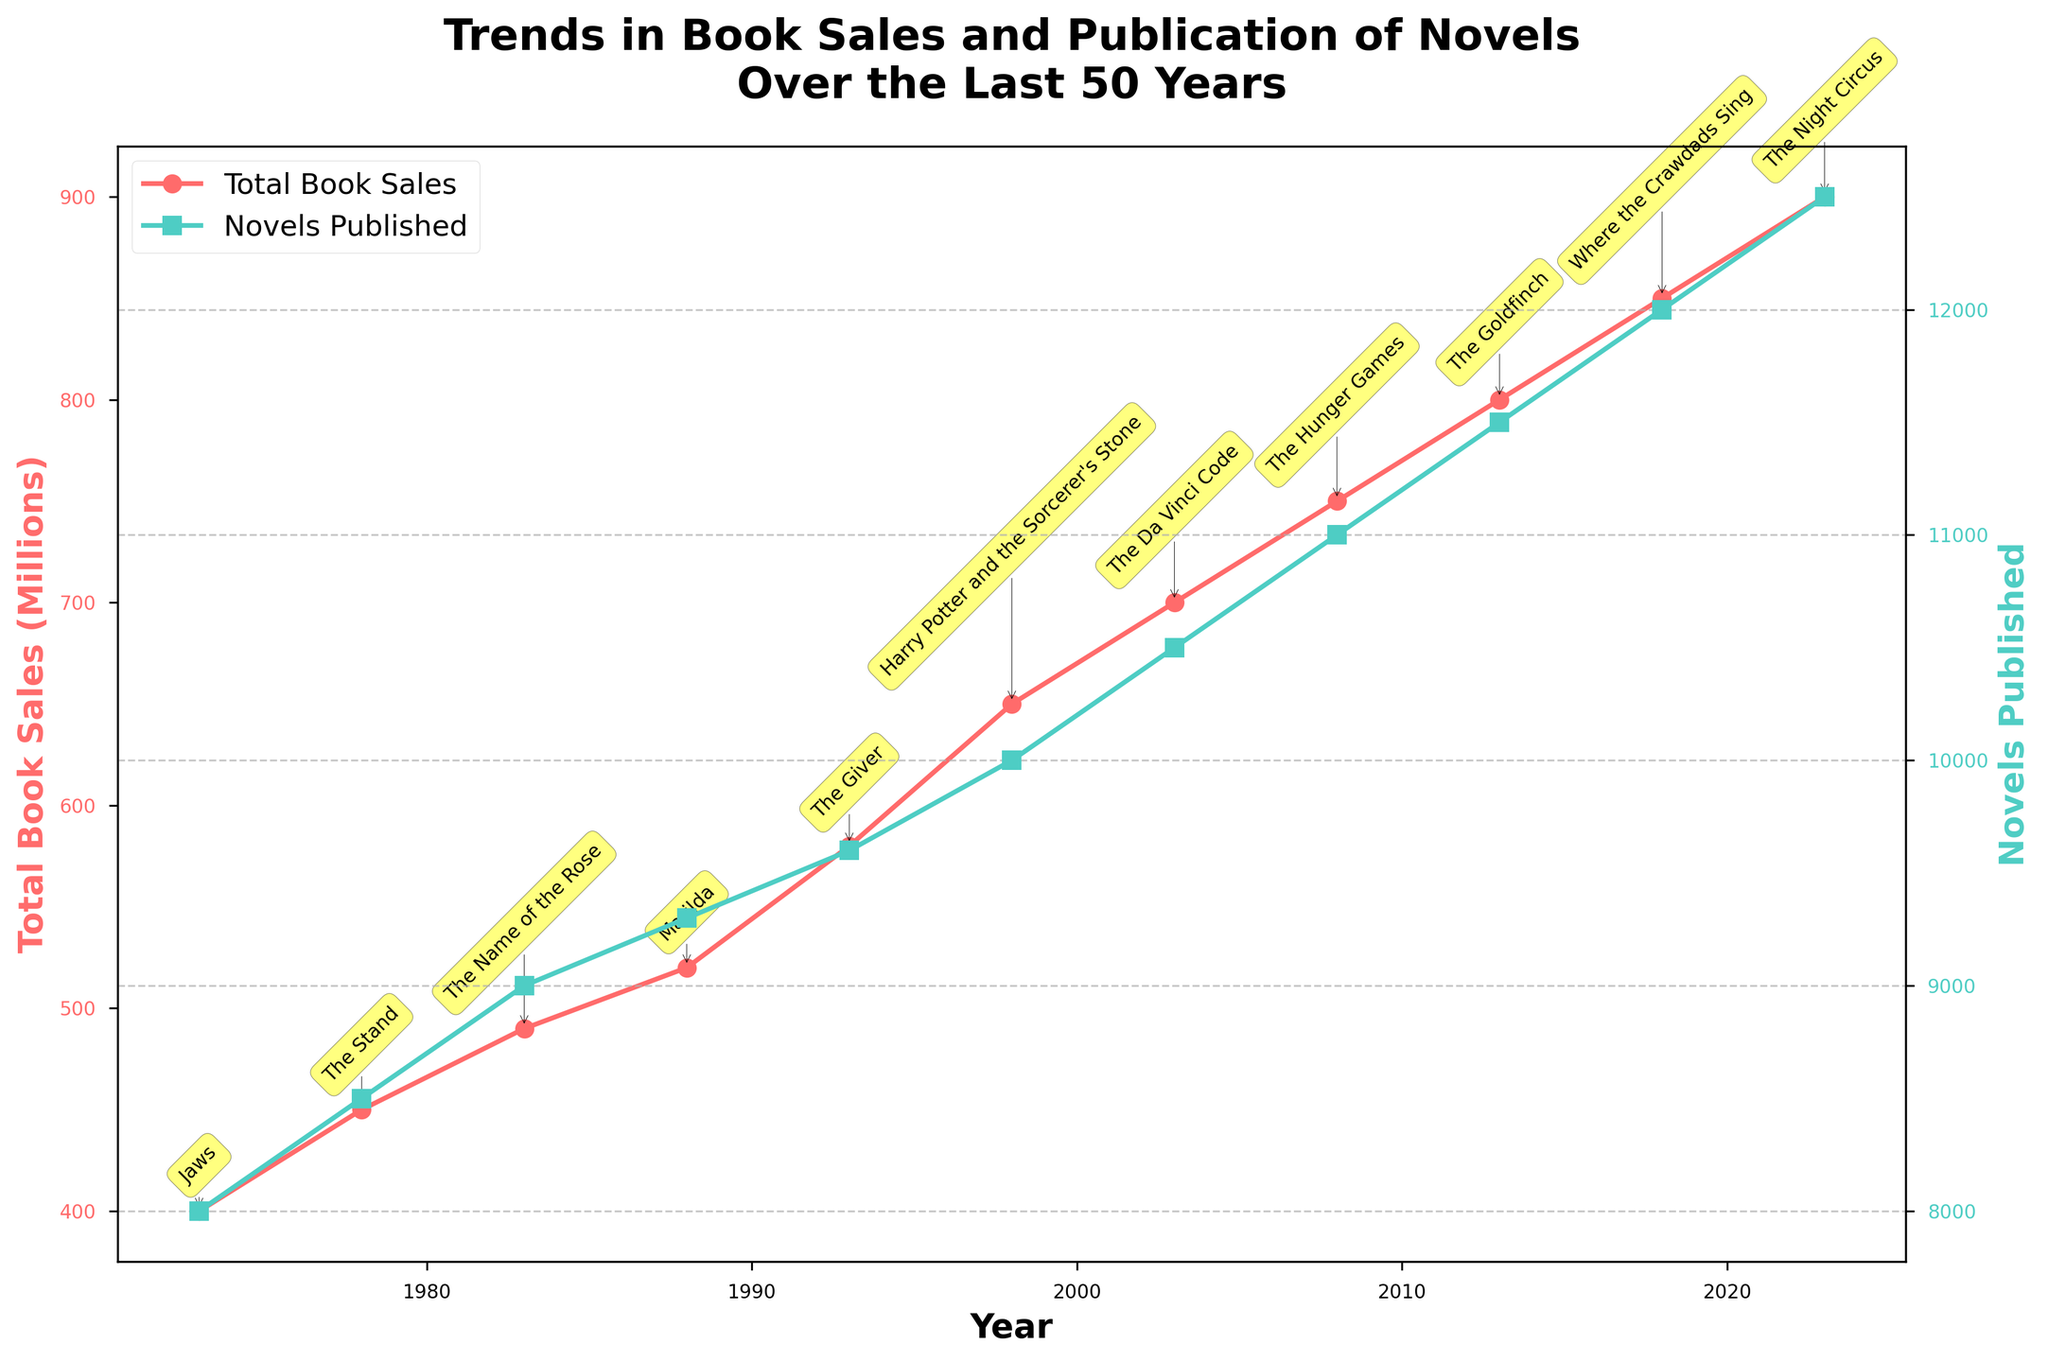What is the title of the plot? The title is typically centered at the top of the plot in a larger font size, providing a clear summary of what the plot is about. By reading this title, we can quickly understand the overall topic of the plot.
Answer: Trends in Book Sales and Publication of Novels Over the Last 50 Years What are the colors used for the two lines representing Total Book Sales and Novels Published? The color of the line for Total Book Sales is marked in red shades, and the line for Novels Published is marked in green shades.
Answer: Red and Green What is the total number of novels published in 2013? Locate the data point for 2013 on the green line (representing Novels Published) and read the corresponding y-axis value on the right side of the plot.
Answer: 11,500 Which year has the highest Total Book Sales? Look for the highest data point on the red line (representing Total Book Sales) and identify the corresponding year on the x-axis.
Answer: 2023 How do the trends in Total Book Sales and Novels Published compare over the last 50 years? Observe both red and green lines from left to right. Both lines generally trend upwards over time, with both Total Book Sales and Novels Published increasing steadily over the years.
Answer: Both are increasing What is the difference in Total Book Sales between 1973 and 2023? Locate the Total Book Sales values for 1973 and 2023 on the red line. Subtract the 1973 value from the 2023 value: 900 million - 400 million.
Answer: 500 million Which best-selling novel is annotated for the year 1998? Check the annotation near the data point for the year 1998 on the red line. The annotation text shows the name of the best-selling novel.
Answer: Harry Potter and the Sorcerer's Stone In which decade did the number of Novels Published first exceed 10,000? Note the green line's trajectory. Observe when it crosses the 10,000 mark and identify the corresponding decade from the x-axis.
Answer: 1990s What is the average increase in Total Book Sales per decade? Calculate the changes in Total Book Sales for each decade, sum them, then divide by the number of decades: [(450-400) + (490-450) + (520-490) + (580-520) + (650-580) + (700-650) + (750-700) + (800-750) + (850-800) + (900-850)] / 10
Answer: 50 million When did the number of Novels Published reach 9,000 for the first time? Locate the point where the green line first intersects the 9,000 mark on the right y-axis and read the corresponding year on the x-axis.
Answer: 1983 